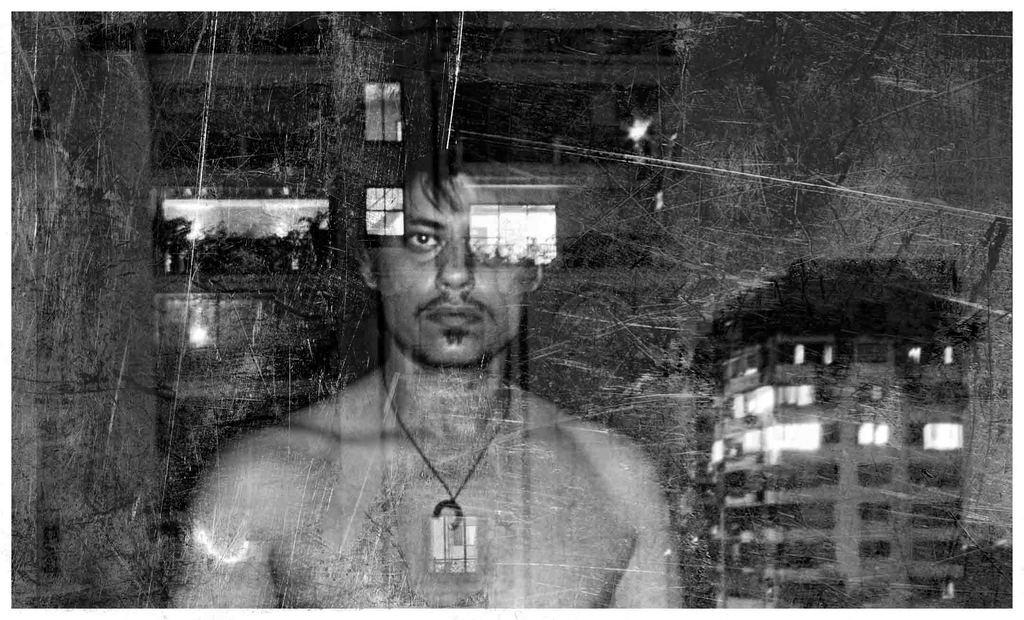What object is present in the image that can hold a liquid? There is a glass in the image. Who or what can be seen through the glass? A person is visible through the glass. What can be seen in the distance behind the glass? There are buildings and plants in the background. Where is the lake located in the image? There is no lake present in the image. What type of porter is assisting the person in the image? There is no porter present in the image. 